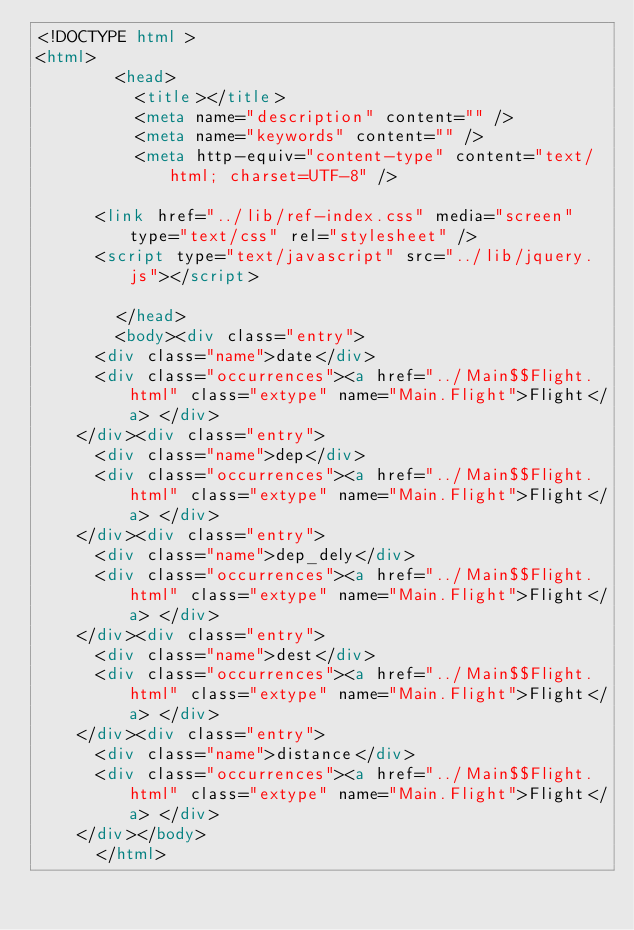<code> <loc_0><loc_0><loc_500><loc_500><_HTML_><!DOCTYPE html >
<html>
        <head>
          <title></title>
          <meta name="description" content="" />
          <meta name="keywords" content="" />
          <meta http-equiv="content-type" content="text/html; charset=UTF-8" />
          
      <link href="../lib/ref-index.css" media="screen" type="text/css" rel="stylesheet" />
      <script type="text/javascript" src="../lib/jquery.js"></script>
    
        </head>
        <body><div class="entry">
      <div class="name">date</div>
      <div class="occurrences"><a href="../Main$$Flight.html" class="extype" name="Main.Flight">Flight</a> </div>
    </div><div class="entry">
      <div class="name">dep</div>
      <div class="occurrences"><a href="../Main$$Flight.html" class="extype" name="Main.Flight">Flight</a> </div>
    </div><div class="entry">
      <div class="name">dep_dely</div>
      <div class="occurrences"><a href="../Main$$Flight.html" class="extype" name="Main.Flight">Flight</a> </div>
    </div><div class="entry">
      <div class="name">dest</div>
      <div class="occurrences"><a href="../Main$$Flight.html" class="extype" name="Main.Flight">Flight</a> </div>
    </div><div class="entry">
      <div class="name">distance</div>
      <div class="occurrences"><a href="../Main$$Flight.html" class="extype" name="Main.Flight">Flight</a> </div>
    </div></body>
      </html>
</code> 